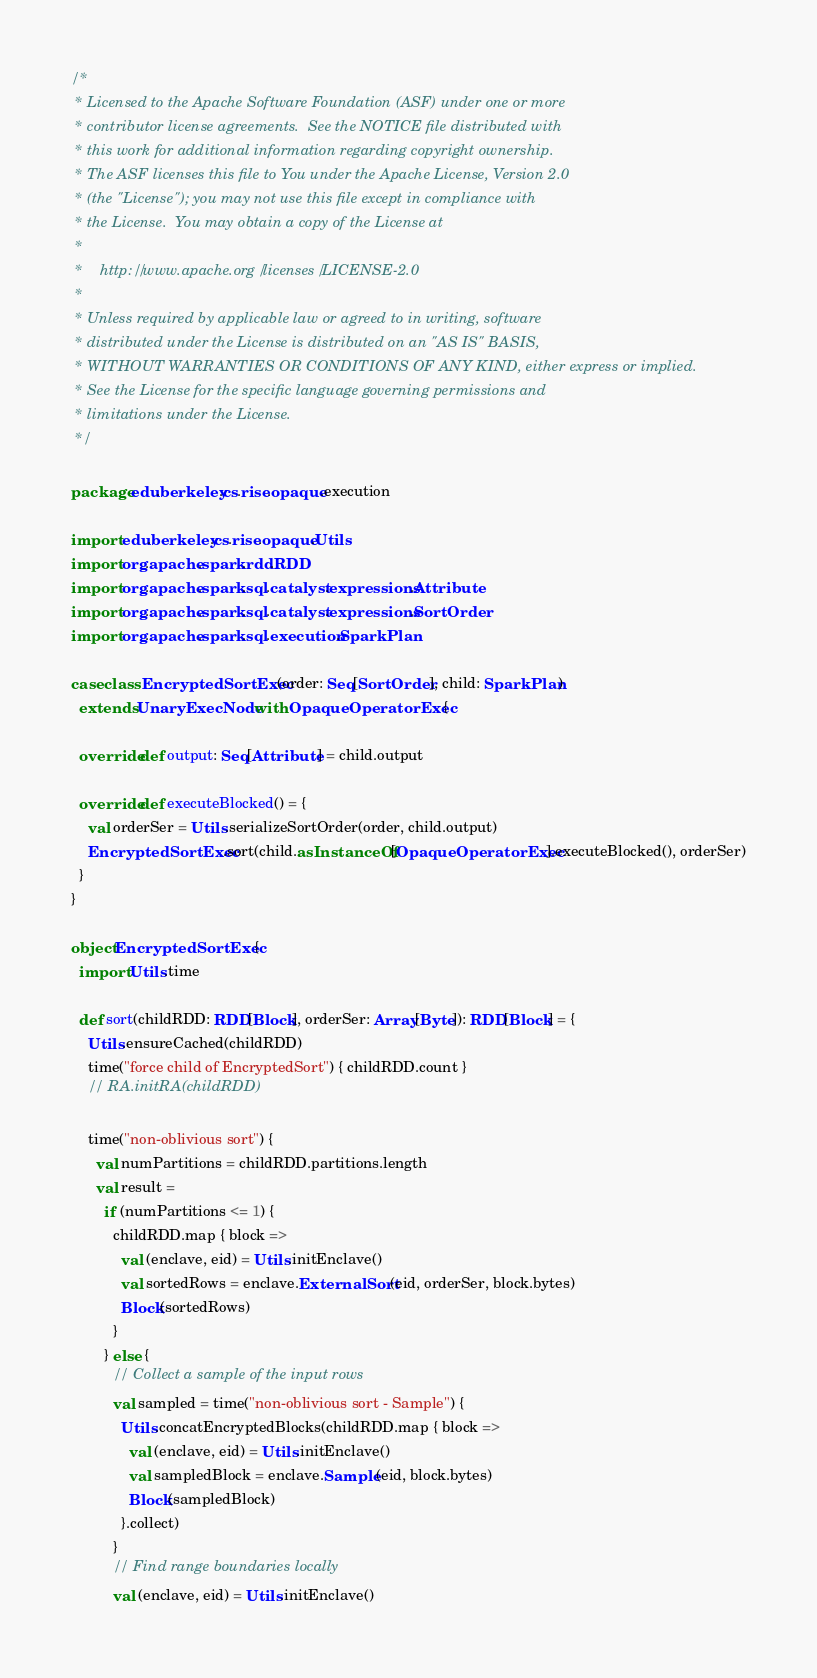Convert code to text. <code><loc_0><loc_0><loc_500><loc_500><_Scala_>/*
 * Licensed to the Apache Software Foundation (ASF) under one or more
 * contributor license agreements.  See the NOTICE file distributed with
 * this work for additional information regarding copyright ownership.
 * The ASF licenses this file to You under the Apache License, Version 2.0
 * (the "License"); you may not use this file except in compliance with
 * the License.  You may obtain a copy of the License at
 *
 *    http://www.apache.org/licenses/LICENSE-2.0
 *
 * Unless required by applicable law or agreed to in writing, software
 * distributed under the License is distributed on an "AS IS" BASIS,
 * WITHOUT WARRANTIES OR CONDITIONS OF ANY KIND, either express or implied.
 * See the License for the specific language governing permissions and
 * limitations under the License.
 */

package edu.berkeley.cs.rise.opaque.execution

import edu.berkeley.cs.rise.opaque.Utils
import org.apache.spark.rdd.RDD
import org.apache.spark.sql.catalyst.expressions.Attribute
import org.apache.spark.sql.catalyst.expressions.SortOrder
import org.apache.spark.sql.execution.SparkPlan

case class EncryptedSortExec(order: Seq[SortOrder], child: SparkPlan)
  extends UnaryExecNode with OpaqueOperatorExec {

  override def output: Seq[Attribute] = child.output

  override def executeBlocked() = {
    val orderSer = Utils.serializeSortOrder(order, child.output)
    EncryptedSortExec.sort(child.asInstanceOf[OpaqueOperatorExec].executeBlocked(), orderSer)
  }
}

object EncryptedSortExec {
  import Utils.time

  def sort(childRDD: RDD[Block], orderSer: Array[Byte]): RDD[Block] = {
    Utils.ensureCached(childRDD)
    time("force child of EncryptedSort") { childRDD.count }
    // RA.initRA(childRDD)

    time("non-oblivious sort") {
      val numPartitions = childRDD.partitions.length
      val result =
        if (numPartitions <= 1) {
          childRDD.map { block =>
            val (enclave, eid) = Utils.initEnclave()
            val sortedRows = enclave.ExternalSort(eid, orderSer, block.bytes)
            Block(sortedRows)
          }
        } else {
          // Collect a sample of the input rows
          val sampled = time("non-oblivious sort - Sample") {
            Utils.concatEncryptedBlocks(childRDD.map { block =>
              val (enclave, eid) = Utils.initEnclave()
              val sampledBlock = enclave.Sample(eid, block.bytes)
              Block(sampledBlock)
            }.collect)
          }
          // Find range boundaries locally
          val (enclave, eid) = Utils.initEnclave()</code> 